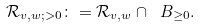Convert formula to latex. <formula><loc_0><loc_0><loc_500><loc_500>\mathcal { R } _ { v , w ; > 0 } \colon = \mathcal { R } _ { v , w } \cap \ B _ { \geq 0 } .</formula> 